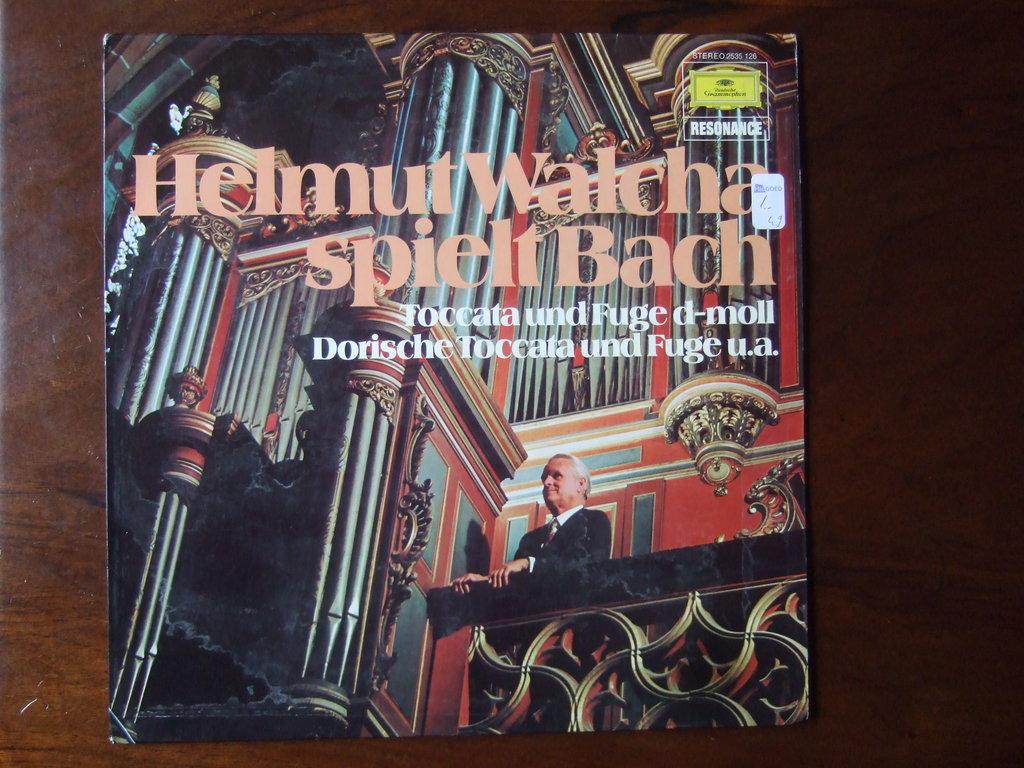What company put out this record?
Keep it short and to the point. Resonance. 